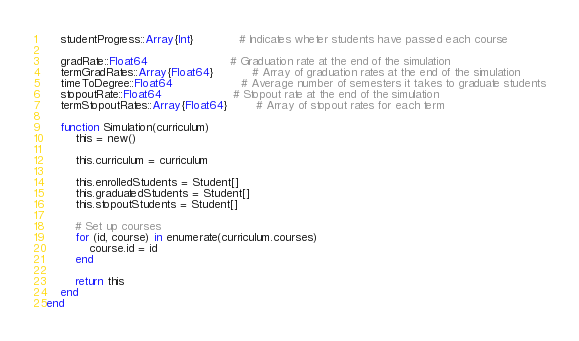Convert code to text. <code><loc_0><loc_0><loc_500><loc_500><_Julia_>    studentProgress::Array{Int}             # Indicates wheter students have passed each course

    gradRate::Float64                       # Graduation rate at the end of the simulation
    termGradRates::Array{Float64}           # Array of graduation rates at the end of the simulation
    timeToDegree::Float64                   # Average number of semesters it takes to graduate students
    stopoutRate::Float64                    # Stopout rate at the end of the simulation
    termStopoutRates::Array{Float64}        # Array of stopout rates for each term

    function Simulation(curriculum)
        this = new()

        this.curriculum = curriculum

        this.enrolledStudents = Student[]
        this.graduatedStudents = Student[]
        this.stopoutStudents = Student[]

        # Set up courses
        for (id, course) in enumerate(curriculum.courses)
            course.id = id
        end

        return this
    end
end</code> 